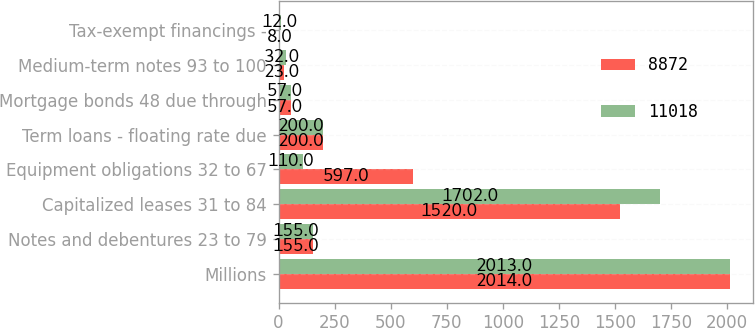Convert chart to OTSL. <chart><loc_0><loc_0><loc_500><loc_500><stacked_bar_chart><ecel><fcel>Millions<fcel>Notes and debentures 23 to 79<fcel>Capitalized leases 31 to 84<fcel>Equipment obligations 32 to 67<fcel>Term loans - floating rate due<fcel>Mortgage bonds 48 due through<fcel>Medium-term notes 93 to 100<fcel>Tax-exempt financings -<nl><fcel>8872<fcel>2014<fcel>155<fcel>1520<fcel>597<fcel>200<fcel>57<fcel>23<fcel>8<nl><fcel>11018<fcel>2013<fcel>155<fcel>1702<fcel>110<fcel>200<fcel>57<fcel>32<fcel>12<nl></chart> 